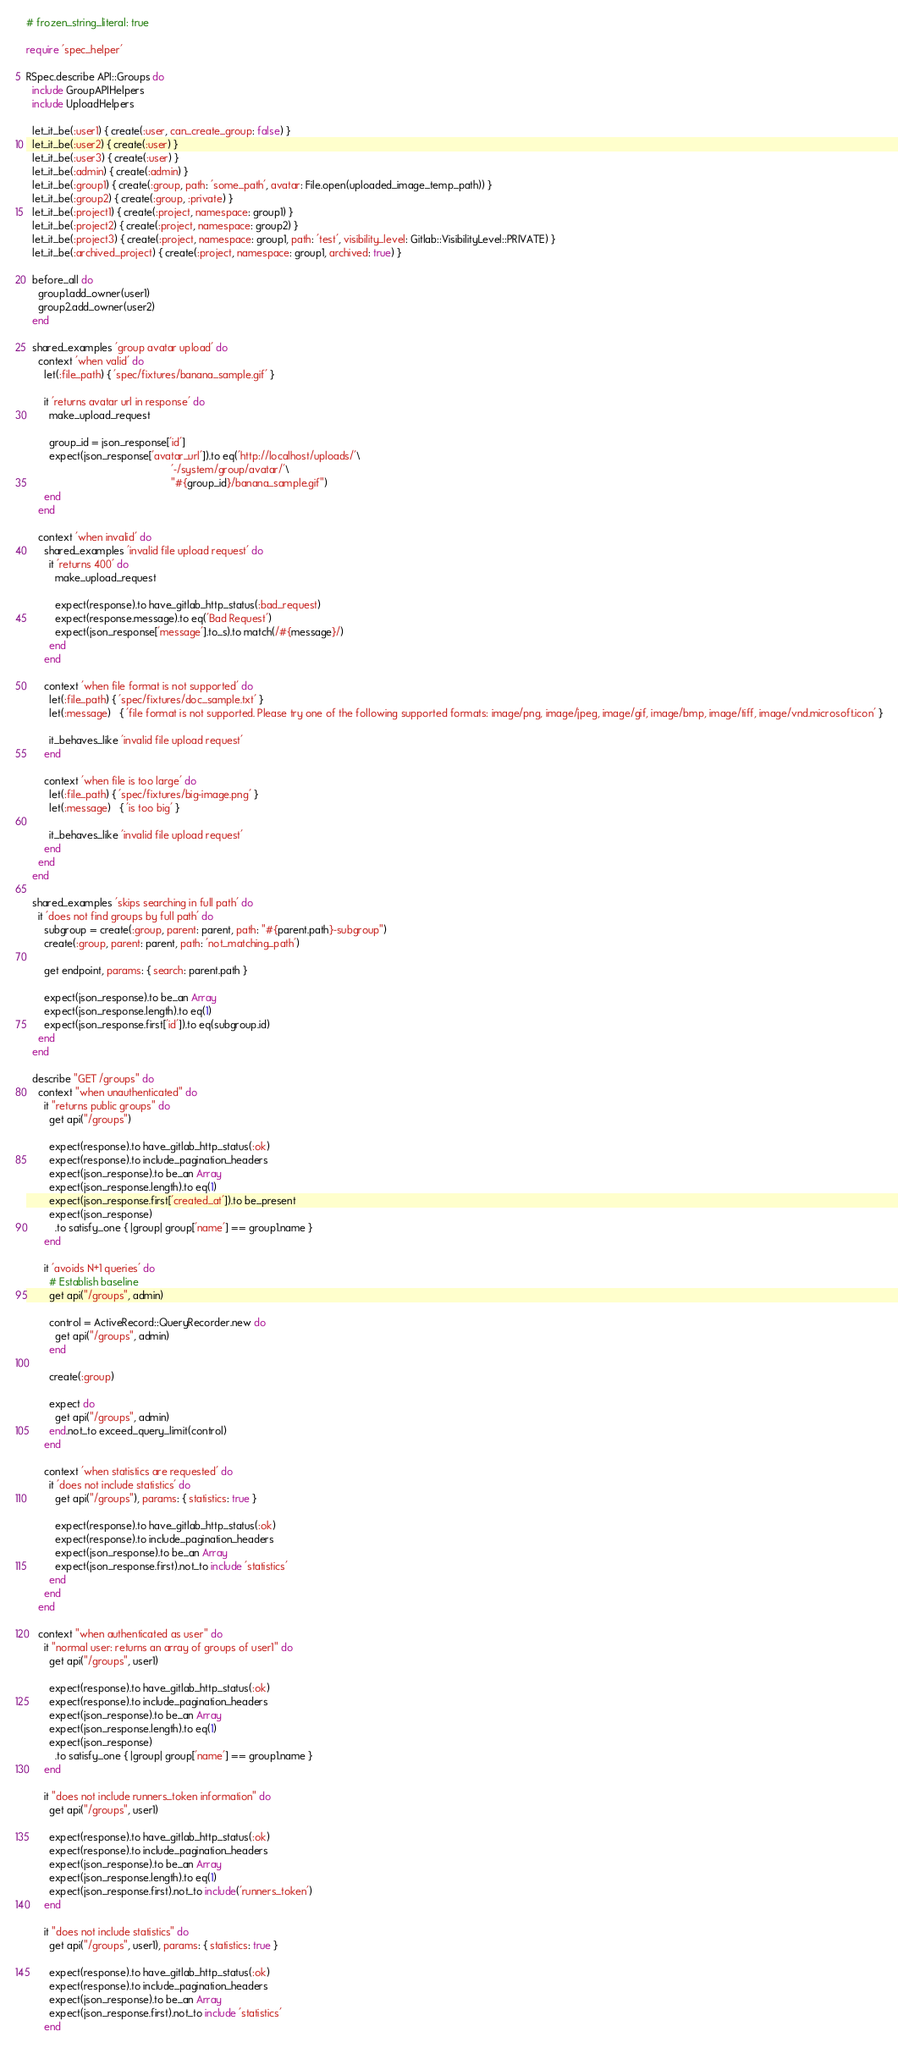Convert code to text. <code><loc_0><loc_0><loc_500><loc_500><_Ruby_># frozen_string_literal: true

require 'spec_helper'

RSpec.describe API::Groups do
  include GroupAPIHelpers
  include UploadHelpers

  let_it_be(:user1) { create(:user, can_create_group: false) }
  let_it_be(:user2) { create(:user) }
  let_it_be(:user3) { create(:user) }
  let_it_be(:admin) { create(:admin) }
  let_it_be(:group1) { create(:group, path: 'some_path', avatar: File.open(uploaded_image_temp_path)) }
  let_it_be(:group2) { create(:group, :private) }
  let_it_be(:project1) { create(:project, namespace: group1) }
  let_it_be(:project2) { create(:project, namespace: group2) }
  let_it_be(:project3) { create(:project, namespace: group1, path: 'test', visibility_level: Gitlab::VisibilityLevel::PRIVATE) }
  let_it_be(:archived_project) { create(:project, namespace: group1, archived: true) }

  before_all do
    group1.add_owner(user1)
    group2.add_owner(user2)
  end

  shared_examples 'group avatar upload' do
    context 'when valid' do
      let(:file_path) { 'spec/fixtures/banana_sample.gif' }

      it 'returns avatar url in response' do
        make_upload_request

        group_id = json_response['id']
        expect(json_response['avatar_url']).to eq('http://localhost/uploads/'\
                                                  '-/system/group/avatar/'\
                                                  "#{group_id}/banana_sample.gif")
      end
    end

    context 'when invalid' do
      shared_examples 'invalid file upload request' do
        it 'returns 400' do
          make_upload_request

          expect(response).to have_gitlab_http_status(:bad_request)
          expect(response.message).to eq('Bad Request')
          expect(json_response['message'].to_s).to match(/#{message}/)
        end
      end

      context 'when file format is not supported' do
        let(:file_path) { 'spec/fixtures/doc_sample.txt' }
        let(:message)   { 'file format is not supported. Please try one of the following supported formats: image/png, image/jpeg, image/gif, image/bmp, image/tiff, image/vnd.microsoft.icon' }

        it_behaves_like 'invalid file upload request'
      end

      context 'when file is too large' do
        let(:file_path) { 'spec/fixtures/big-image.png' }
        let(:message)   { 'is too big' }

        it_behaves_like 'invalid file upload request'
      end
    end
  end

  shared_examples 'skips searching in full path' do
    it 'does not find groups by full path' do
      subgroup = create(:group, parent: parent, path: "#{parent.path}-subgroup")
      create(:group, parent: parent, path: 'not_matching_path')

      get endpoint, params: { search: parent.path }

      expect(json_response).to be_an Array
      expect(json_response.length).to eq(1)
      expect(json_response.first['id']).to eq(subgroup.id)
    end
  end

  describe "GET /groups" do
    context "when unauthenticated" do
      it "returns public groups" do
        get api("/groups")

        expect(response).to have_gitlab_http_status(:ok)
        expect(response).to include_pagination_headers
        expect(json_response).to be_an Array
        expect(json_response.length).to eq(1)
        expect(json_response.first['created_at']).to be_present
        expect(json_response)
          .to satisfy_one { |group| group['name'] == group1.name }
      end

      it 'avoids N+1 queries' do
        # Establish baseline
        get api("/groups", admin)

        control = ActiveRecord::QueryRecorder.new do
          get api("/groups", admin)
        end

        create(:group)

        expect do
          get api("/groups", admin)
        end.not_to exceed_query_limit(control)
      end

      context 'when statistics are requested' do
        it 'does not include statistics' do
          get api("/groups"), params: { statistics: true }

          expect(response).to have_gitlab_http_status(:ok)
          expect(response).to include_pagination_headers
          expect(json_response).to be_an Array
          expect(json_response.first).not_to include 'statistics'
        end
      end
    end

    context "when authenticated as user" do
      it "normal user: returns an array of groups of user1" do
        get api("/groups", user1)

        expect(response).to have_gitlab_http_status(:ok)
        expect(response).to include_pagination_headers
        expect(json_response).to be_an Array
        expect(json_response.length).to eq(1)
        expect(json_response)
          .to satisfy_one { |group| group['name'] == group1.name }
      end

      it "does not include runners_token information" do
        get api("/groups", user1)

        expect(response).to have_gitlab_http_status(:ok)
        expect(response).to include_pagination_headers
        expect(json_response).to be_an Array
        expect(json_response.length).to eq(1)
        expect(json_response.first).not_to include('runners_token')
      end

      it "does not include statistics" do
        get api("/groups", user1), params: { statistics: true }

        expect(response).to have_gitlab_http_status(:ok)
        expect(response).to include_pagination_headers
        expect(json_response).to be_an Array
        expect(json_response.first).not_to include 'statistics'
      end
</code> 